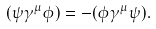<formula> <loc_0><loc_0><loc_500><loc_500>( \psi \gamma ^ { \mu } \phi ) = - ( \phi \gamma ^ { \mu } \psi ) .</formula> 